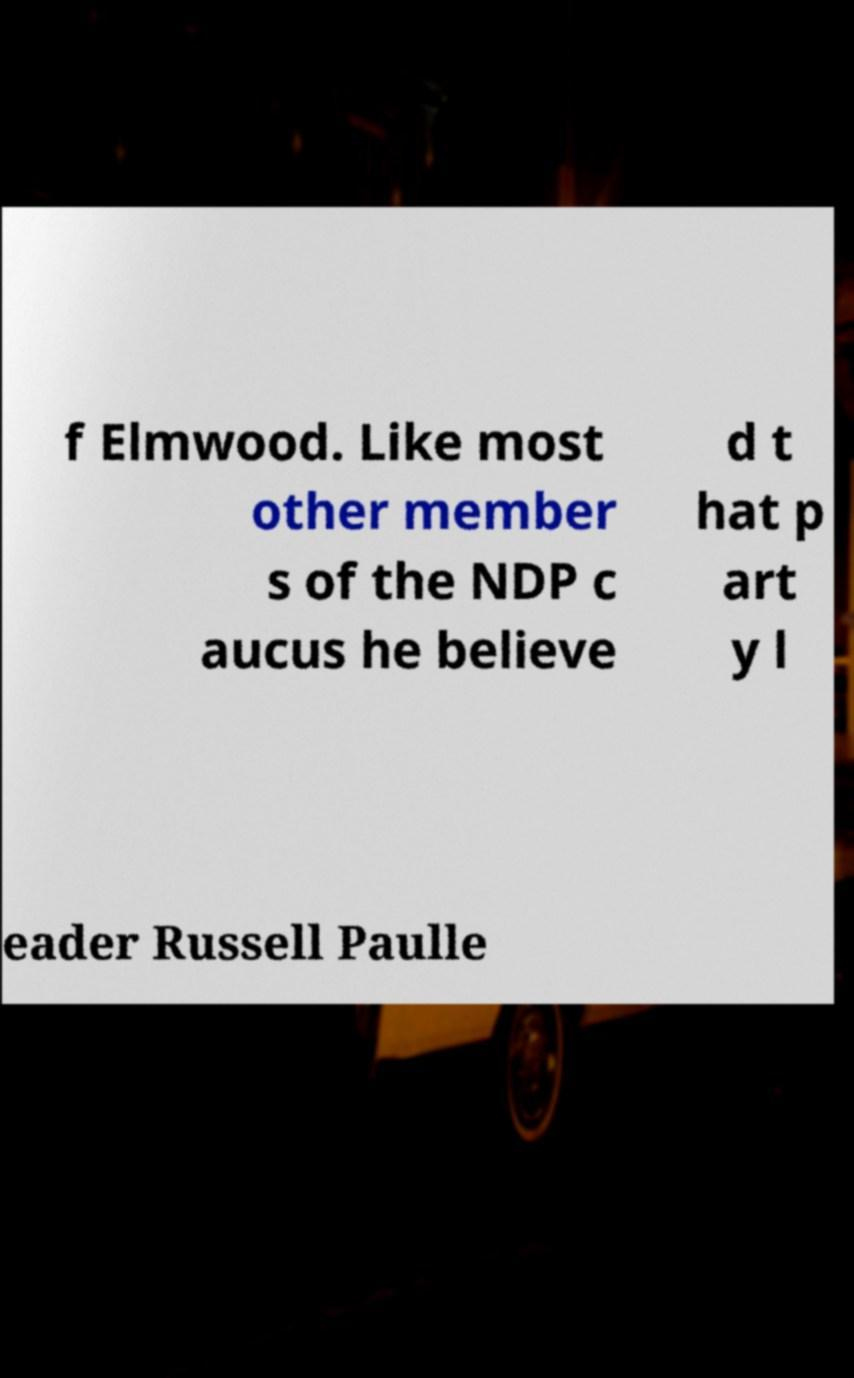What messages or text are displayed in this image? I need them in a readable, typed format. f Elmwood. Like most other member s of the NDP c aucus he believe d t hat p art y l eader Russell Paulle 